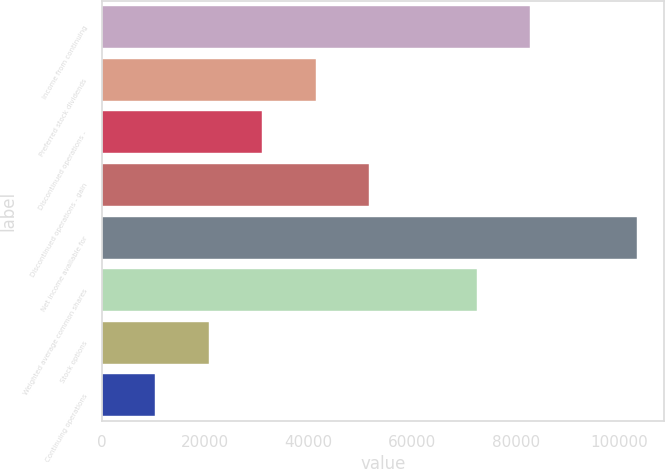Convert chart to OTSL. <chart><loc_0><loc_0><loc_500><loc_500><bar_chart><fcel>Income from continuing<fcel>Preferred stock dividends<fcel>Discontinued operations -<fcel>Discontinued operations - gain<fcel>Net income available for<fcel>Weighted average common shares<fcel>Stock options<fcel>Continuing operations<nl><fcel>82811.3<fcel>41405.8<fcel>31054.5<fcel>51757.2<fcel>103514<fcel>72459.9<fcel>20703.1<fcel>10351.8<nl></chart> 